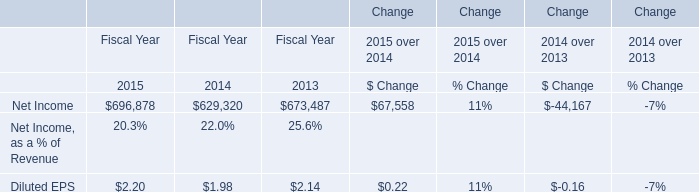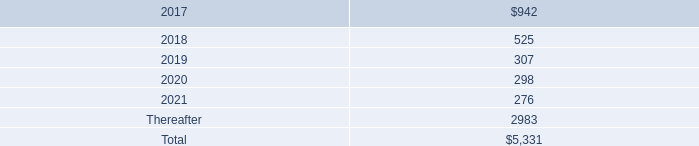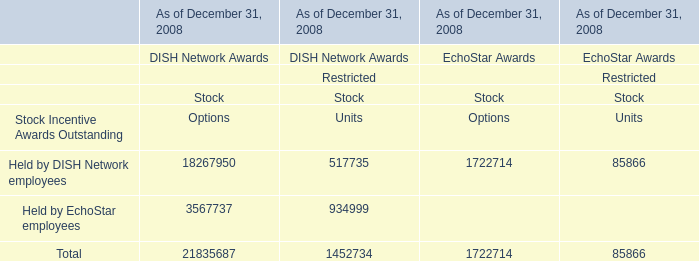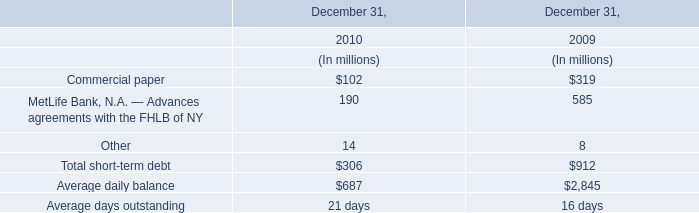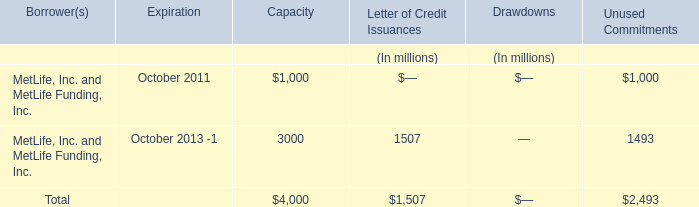What's the average of Net Income of Change Fiscal Year 2013, and MetLife, Inc. and MetLife Funding, Inc. of Unused Commitments ? 
Computations: ((673487.0 + 1493.0) / 2)
Answer: 337490.0. 